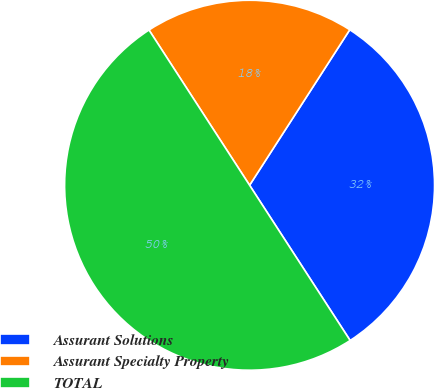Convert chart. <chart><loc_0><loc_0><loc_500><loc_500><pie_chart><fcel>Assurant Solutions<fcel>Assurant Specialty Property<fcel>TOTAL<nl><fcel>31.74%<fcel>18.26%<fcel>50.0%<nl></chart> 